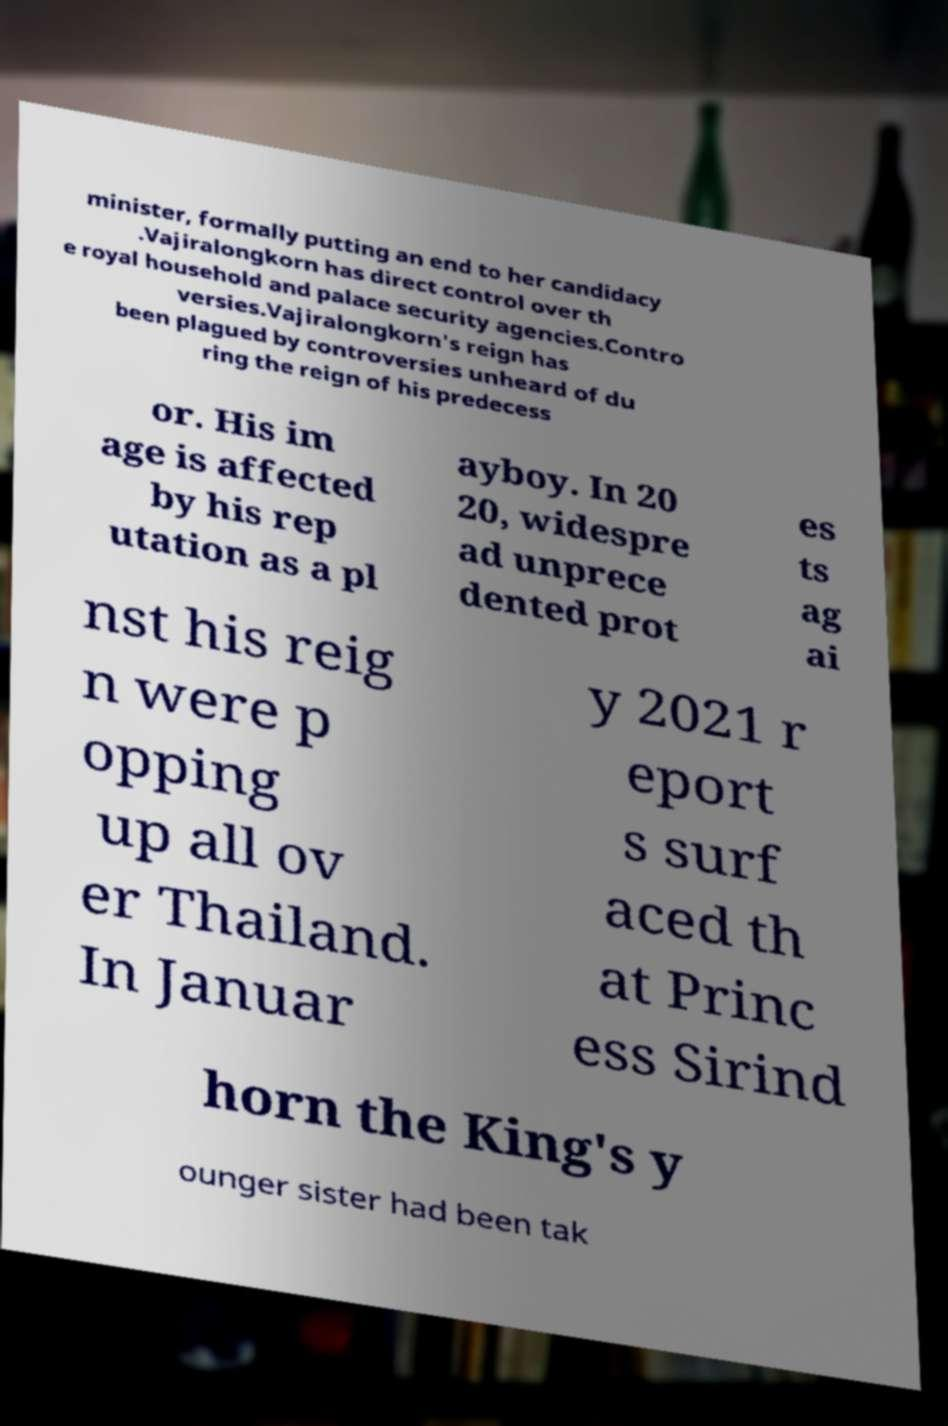I need the written content from this picture converted into text. Can you do that? minister, formally putting an end to her candidacy .Vajiralongkorn has direct control over th e royal household and palace security agencies.Contro versies.Vajiralongkorn's reign has been plagued by controversies unheard of du ring the reign of his predecess or. His im age is affected by his rep utation as a pl ayboy. In 20 20, widespre ad unprece dented prot es ts ag ai nst his reig n were p opping up all ov er Thailand. In Januar y 2021 r eport s surf aced th at Princ ess Sirind horn the King's y ounger sister had been tak 